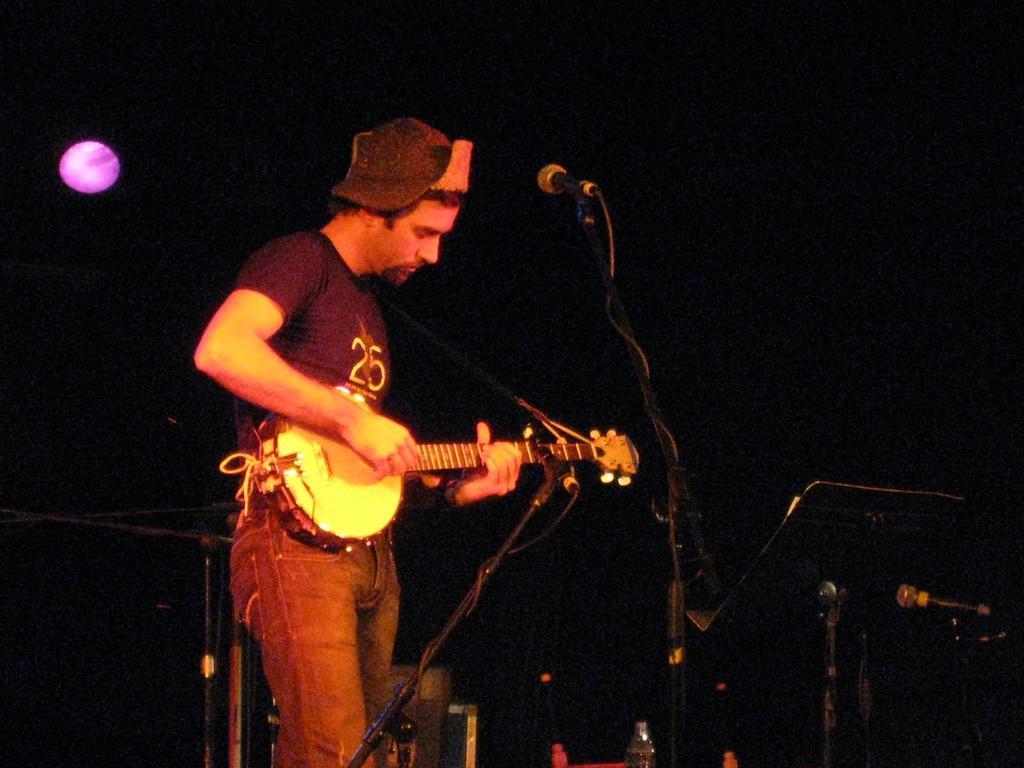How would you summarize this image in a sentence or two? There is a person standing on the left side. He is playing a guitar. Here we can see a microphone. 